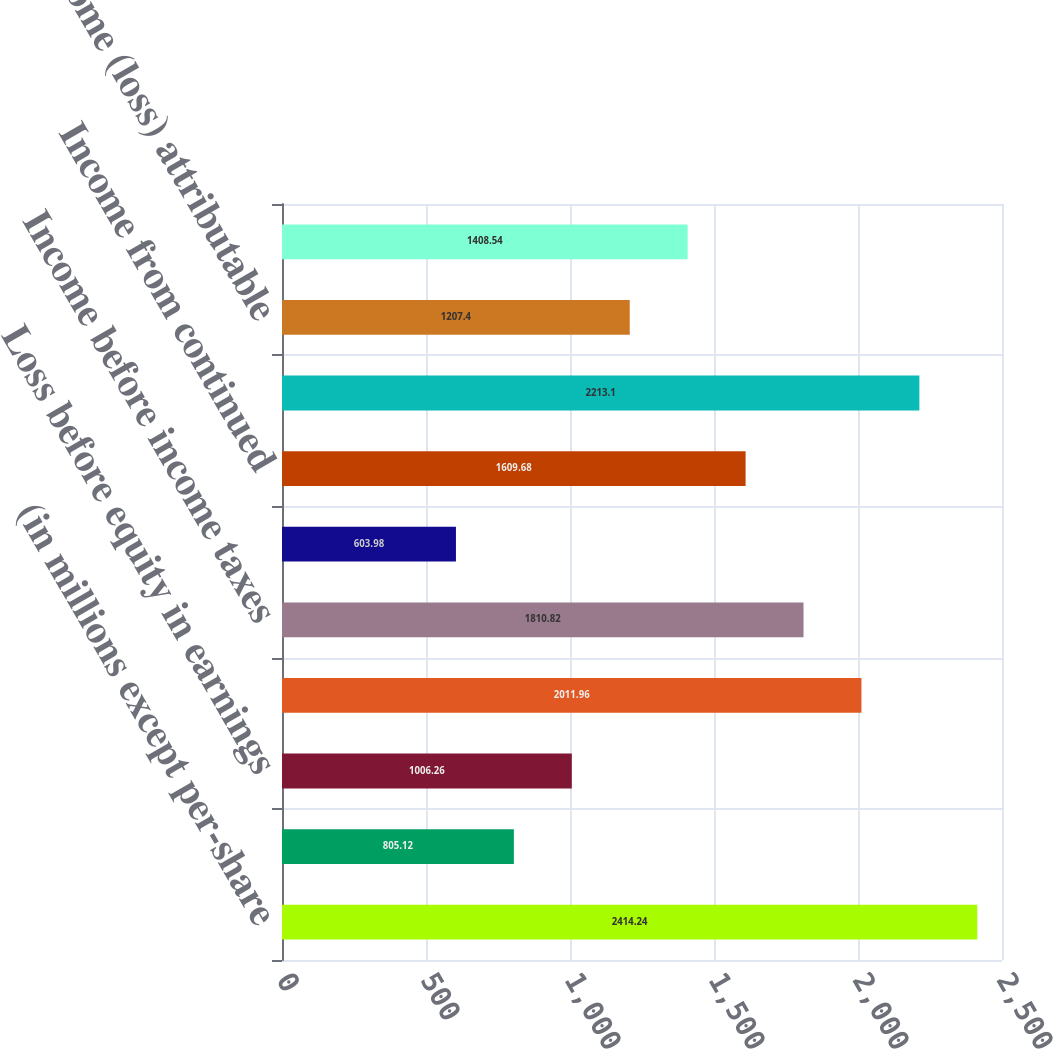<chart> <loc_0><loc_0><loc_500><loc_500><bar_chart><fcel>(in millions except per-share<fcel>Operating expenses and<fcel>Loss before equity in earnings<fcel>Equity in earnings of<fcel>Income before income taxes<fcel>Income tax expense (benefit)<fcel>Income from continued<fcel>Income (loss) from<fcel>Net income (loss) attributable<fcel>Weighted-average common stock<nl><fcel>2414.24<fcel>805.12<fcel>1006.26<fcel>2011.96<fcel>1810.82<fcel>603.98<fcel>1609.68<fcel>2213.1<fcel>1207.4<fcel>1408.54<nl></chart> 